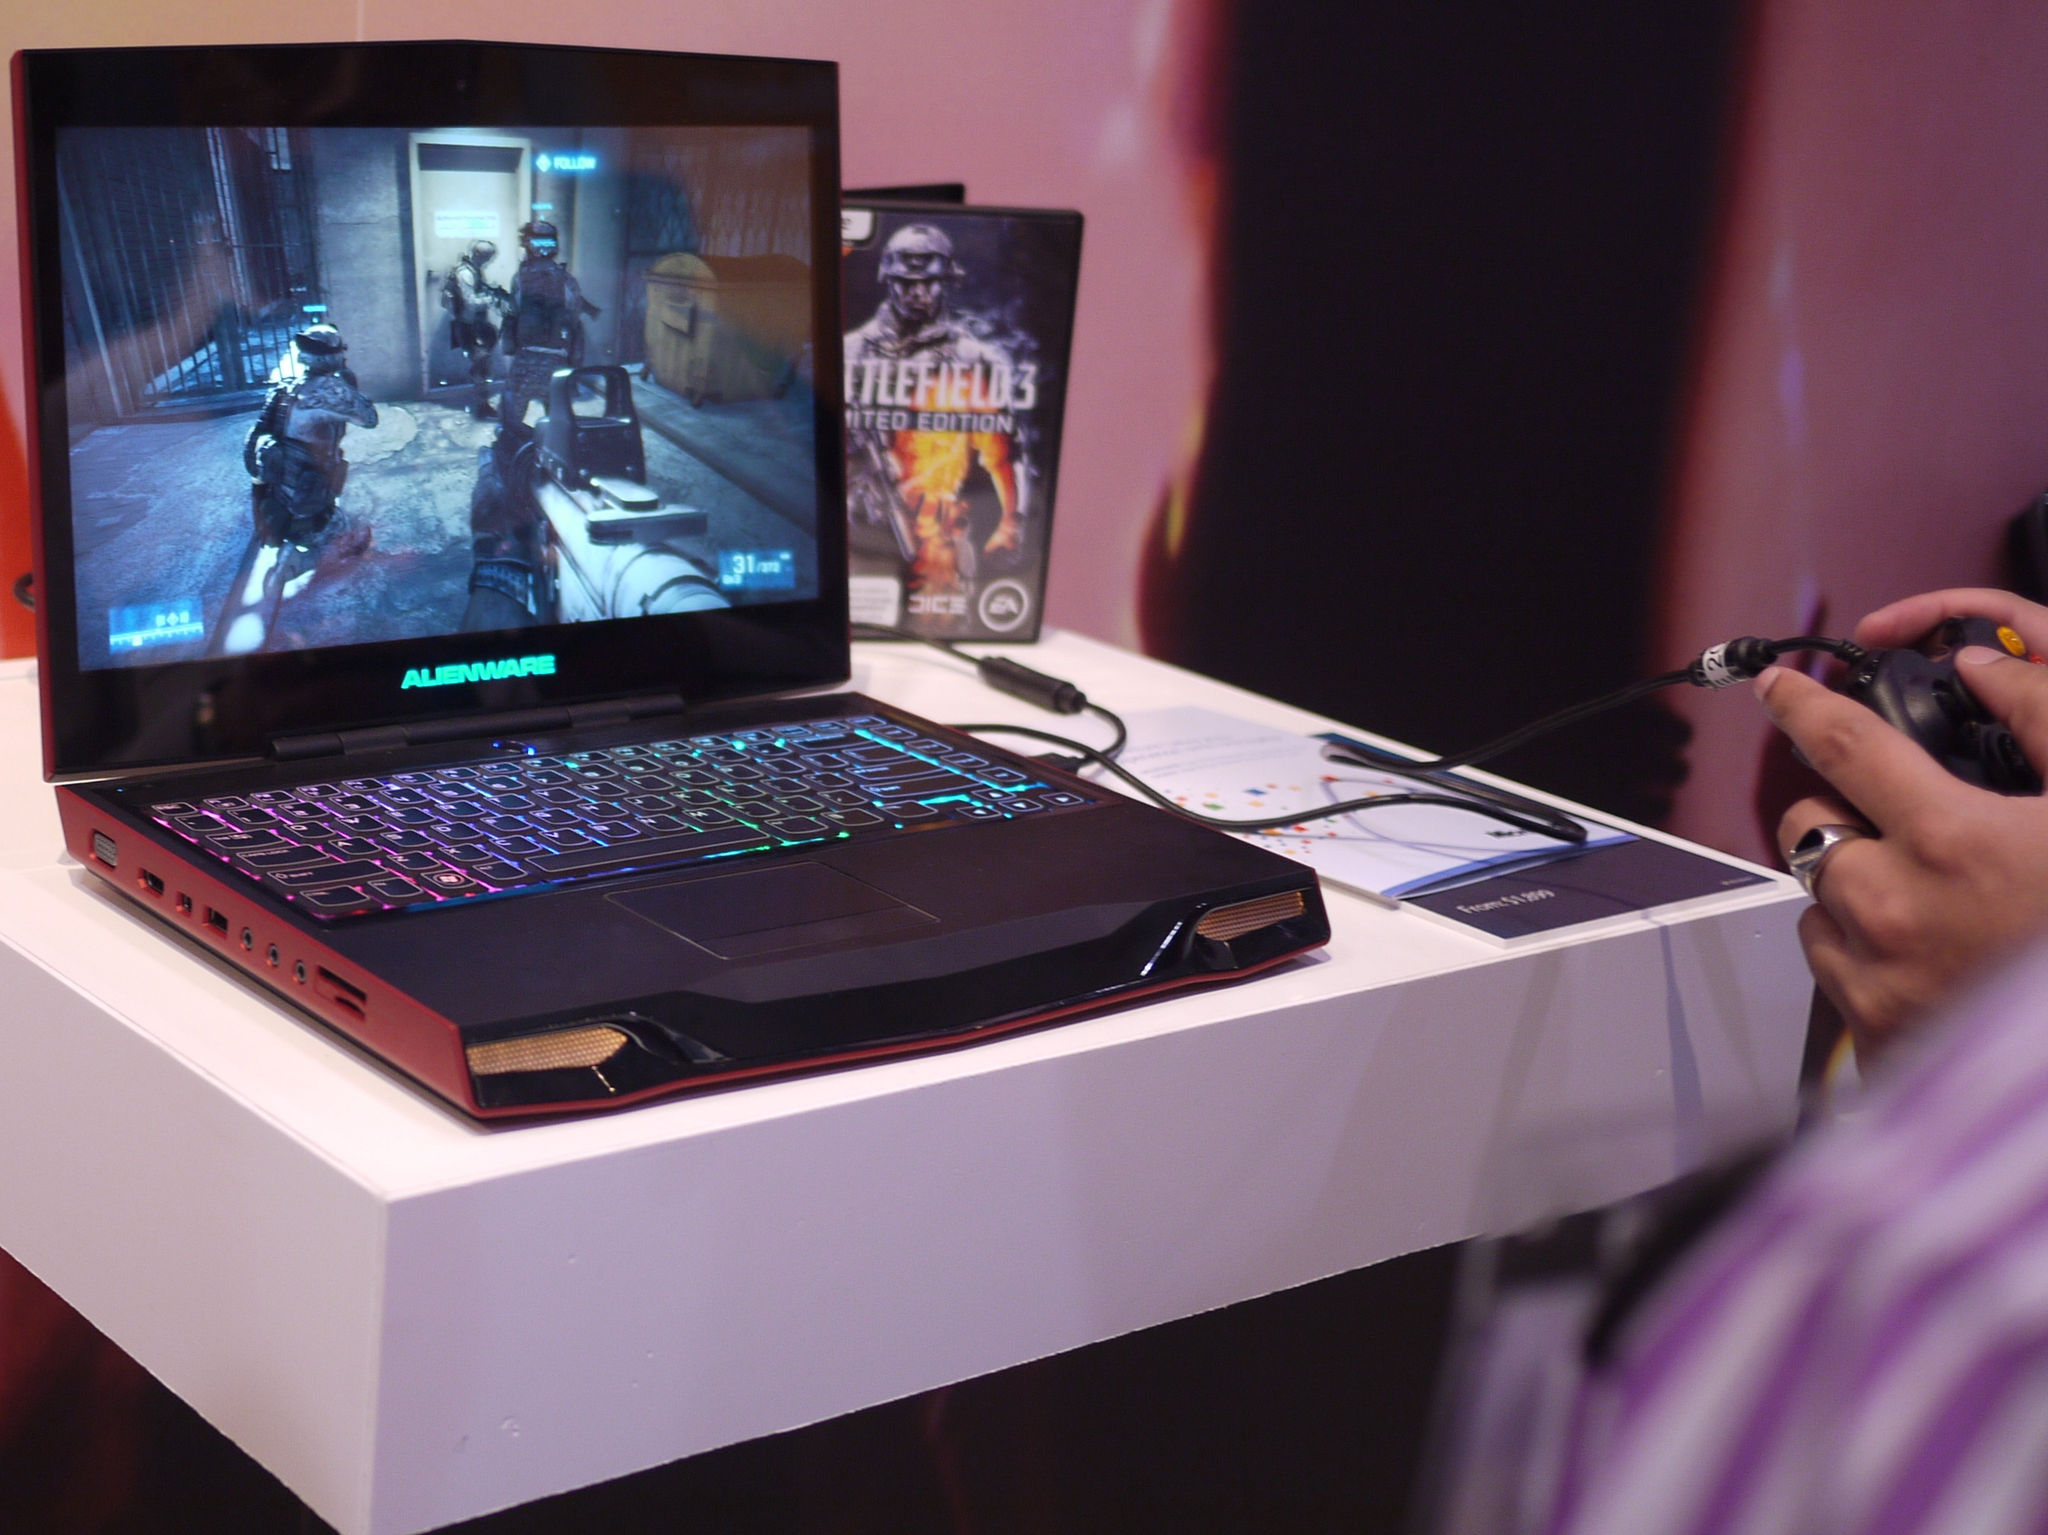What game is shown on the right?
Your answer should be compact. Battlefield 3. What is the monitor brand?
Offer a terse response. Alienware. 